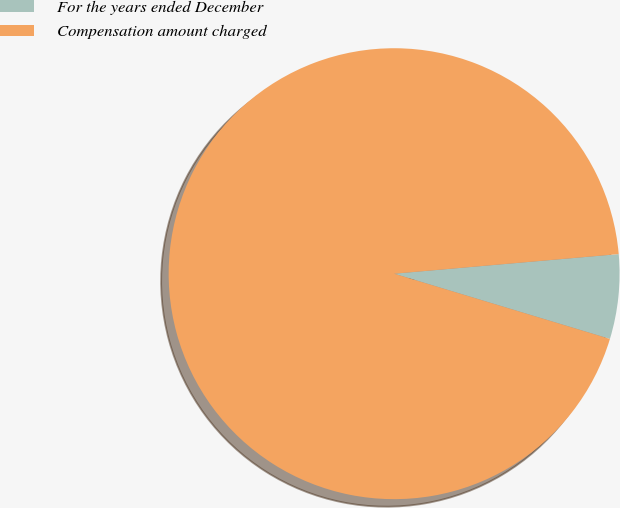Convert chart to OTSL. <chart><loc_0><loc_0><loc_500><loc_500><pie_chart><fcel>For the years ended December<fcel>Compensation amount charged<nl><fcel>6.06%<fcel>93.94%<nl></chart> 